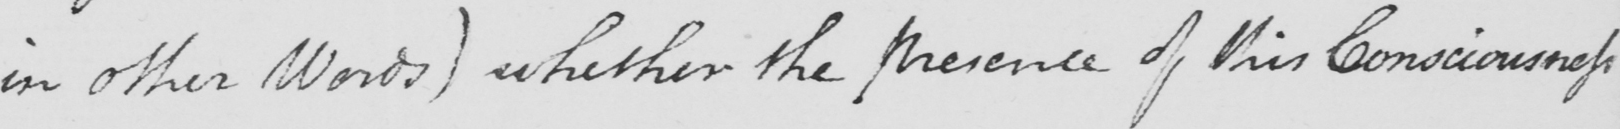Please provide the text content of this handwritten line. in other Words )  whether the presence of this Consciousness 